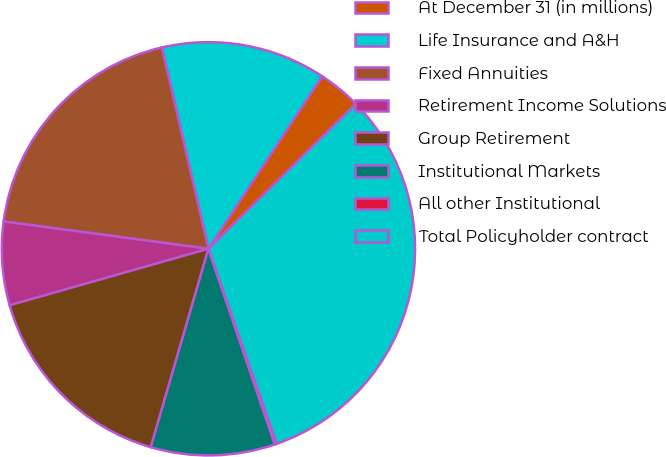Convert chart. <chart><loc_0><loc_0><loc_500><loc_500><pie_chart><fcel>At December 31 (in millions)<fcel>Life Insurance and A&H<fcel>Fixed Annuities<fcel>Retirement Income Solutions<fcel>Group Retirement<fcel>Institutional Markets<fcel>All other Institutional<fcel>Total Policyholder contract<nl><fcel>3.34%<fcel>12.9%<fcel>19.27%<fcel>6.52%<fcel>16.09%<fcel>9.71%<fcel>0.15%<fcel>32.02%<nl></chart> 